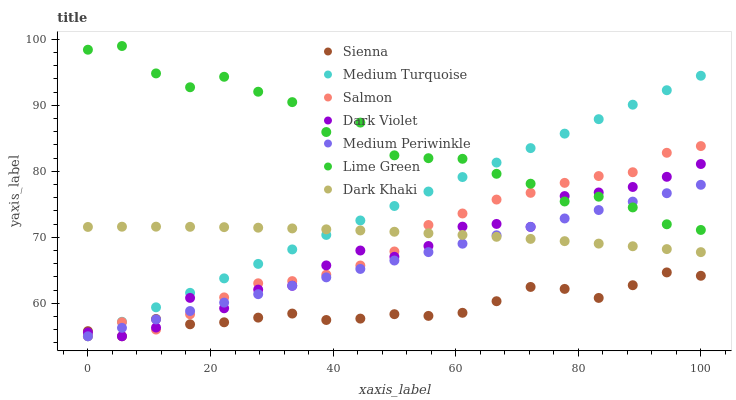Does Sienna have the minimum area under the curve?
Answer yes or no. Yes. Does Lime Green have the maximum area under the curve?
Answer yes or no. Yes. Does Salmon have the minimum area under the curve?
Answer yes or no. No. Does Salmon have the maximum area under the curve?
Answer yes or no. No. Is Medium Turquoise the smoothest?
Answer yes or no. Yes. Is Lime Green the roughest?
Answer yes or no. Yes. Is Salmon the smoothest?
Answer yes or no. No. Is Salmon the roughest?
Answer yes or no. No. Does Salmon have the lowest value?
Answer yes or no. Yes. Does Lime Green have the lowest value?
Answer yes or no. No. Does Lime Green have the highest value?
Answer yes or no. Yes. Does Salmon have the highest value?
Answer yes or no. No. Is Sienna less than Dark Khaki?
Answer yes or no. Yes. Is Lime Green greater than Dark Khaki?
Answer yes or no. Yes. Does Salmon intersect Sienna?
Answer yes or no. Yes. Is Salmon less than Sienna?
Answer yes or no. No. Is Salmon greater than Sienna?
Answer yes or no. No. Does Sienna intersect Dark Khaki?
Answer yes or no. No. 